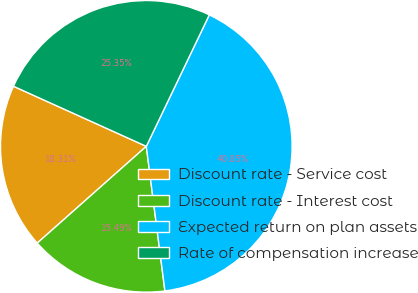Convert chart to OTSL. <chart><loc_0><loc_0><loc_500><loc_500><pie_chart><fcel>Discount rate - Service cost<fcel>Discount rate - Interest cost<fcel>Expected return on plan assets<fcel>Rate of compensation increase<nl><fcel>18.31%<fcel>15.49%<fcel>40.85%<fcel>25.35%<nl></chart> 